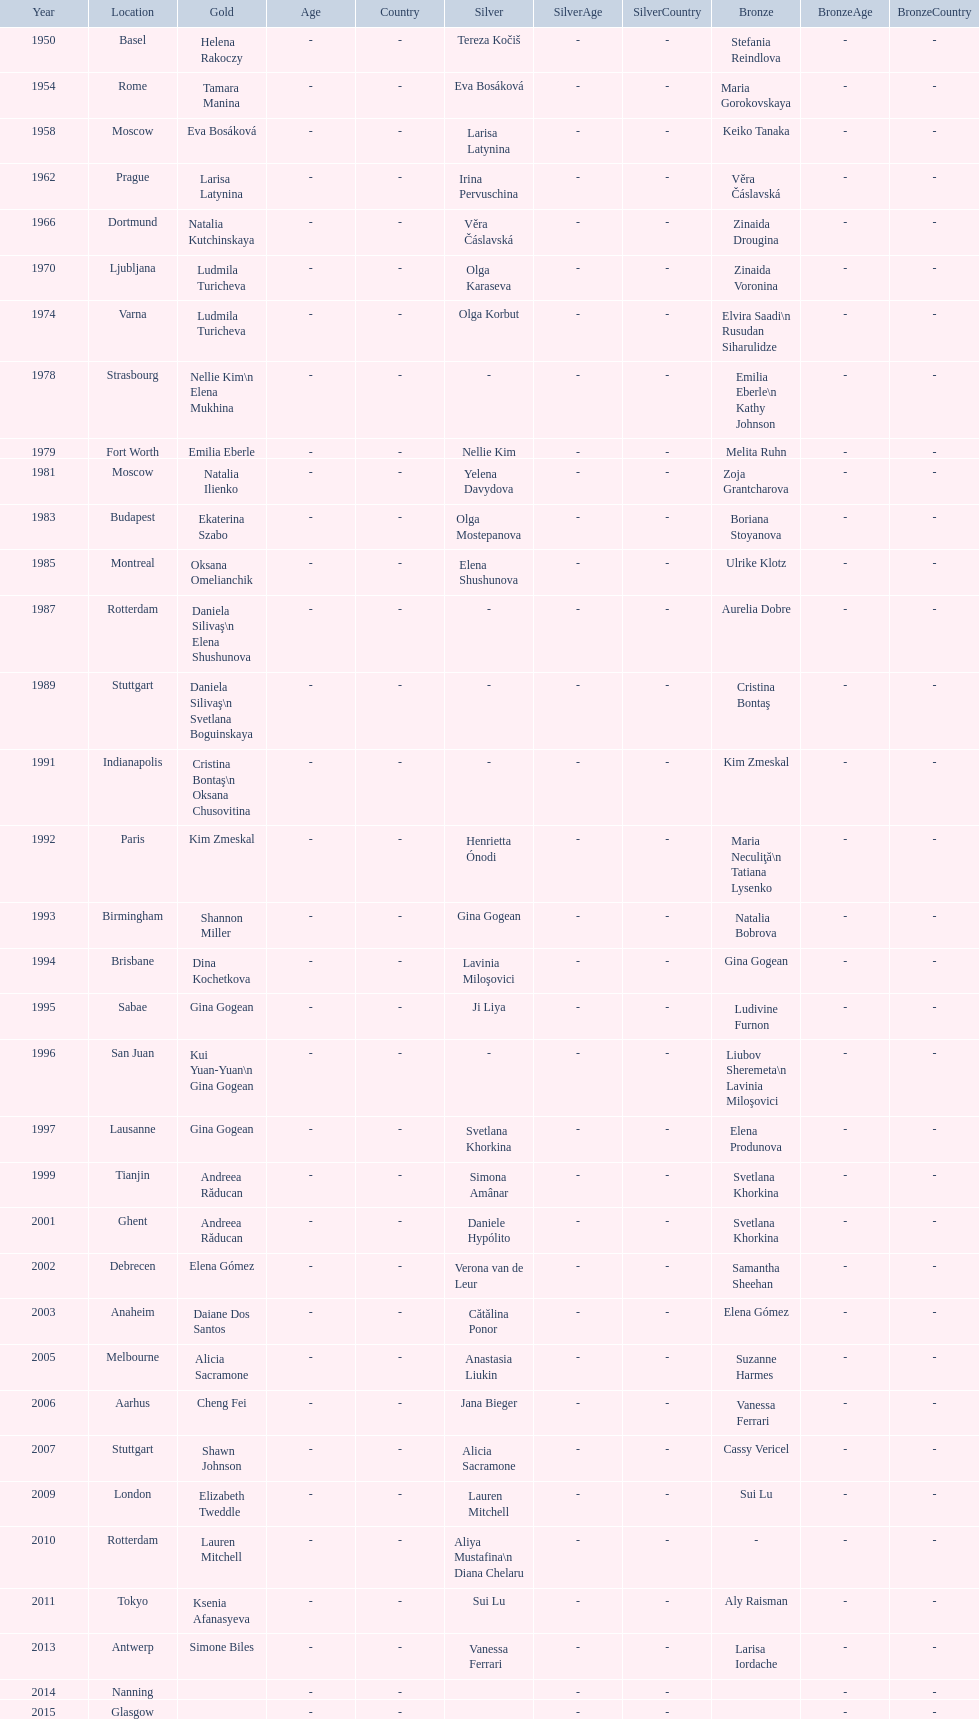What is the total number of russian gymnasts that have won silver. 8. 